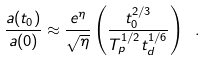<formula> <loc_0><loc_0><loc_500><loc_500>\frac { a ( t _ { 0 } ) } { a ( 0 ) } \approx \frac { e ^ { \eta } } { \sqrt { \eta } } \left ( \frac { t _ { 0 } ^ { 2 / 3 } } { T _ { p } ^ { 1 / 2 } t _ { d } ^ { 1 / 6 } } \right ) \ .</formula> 